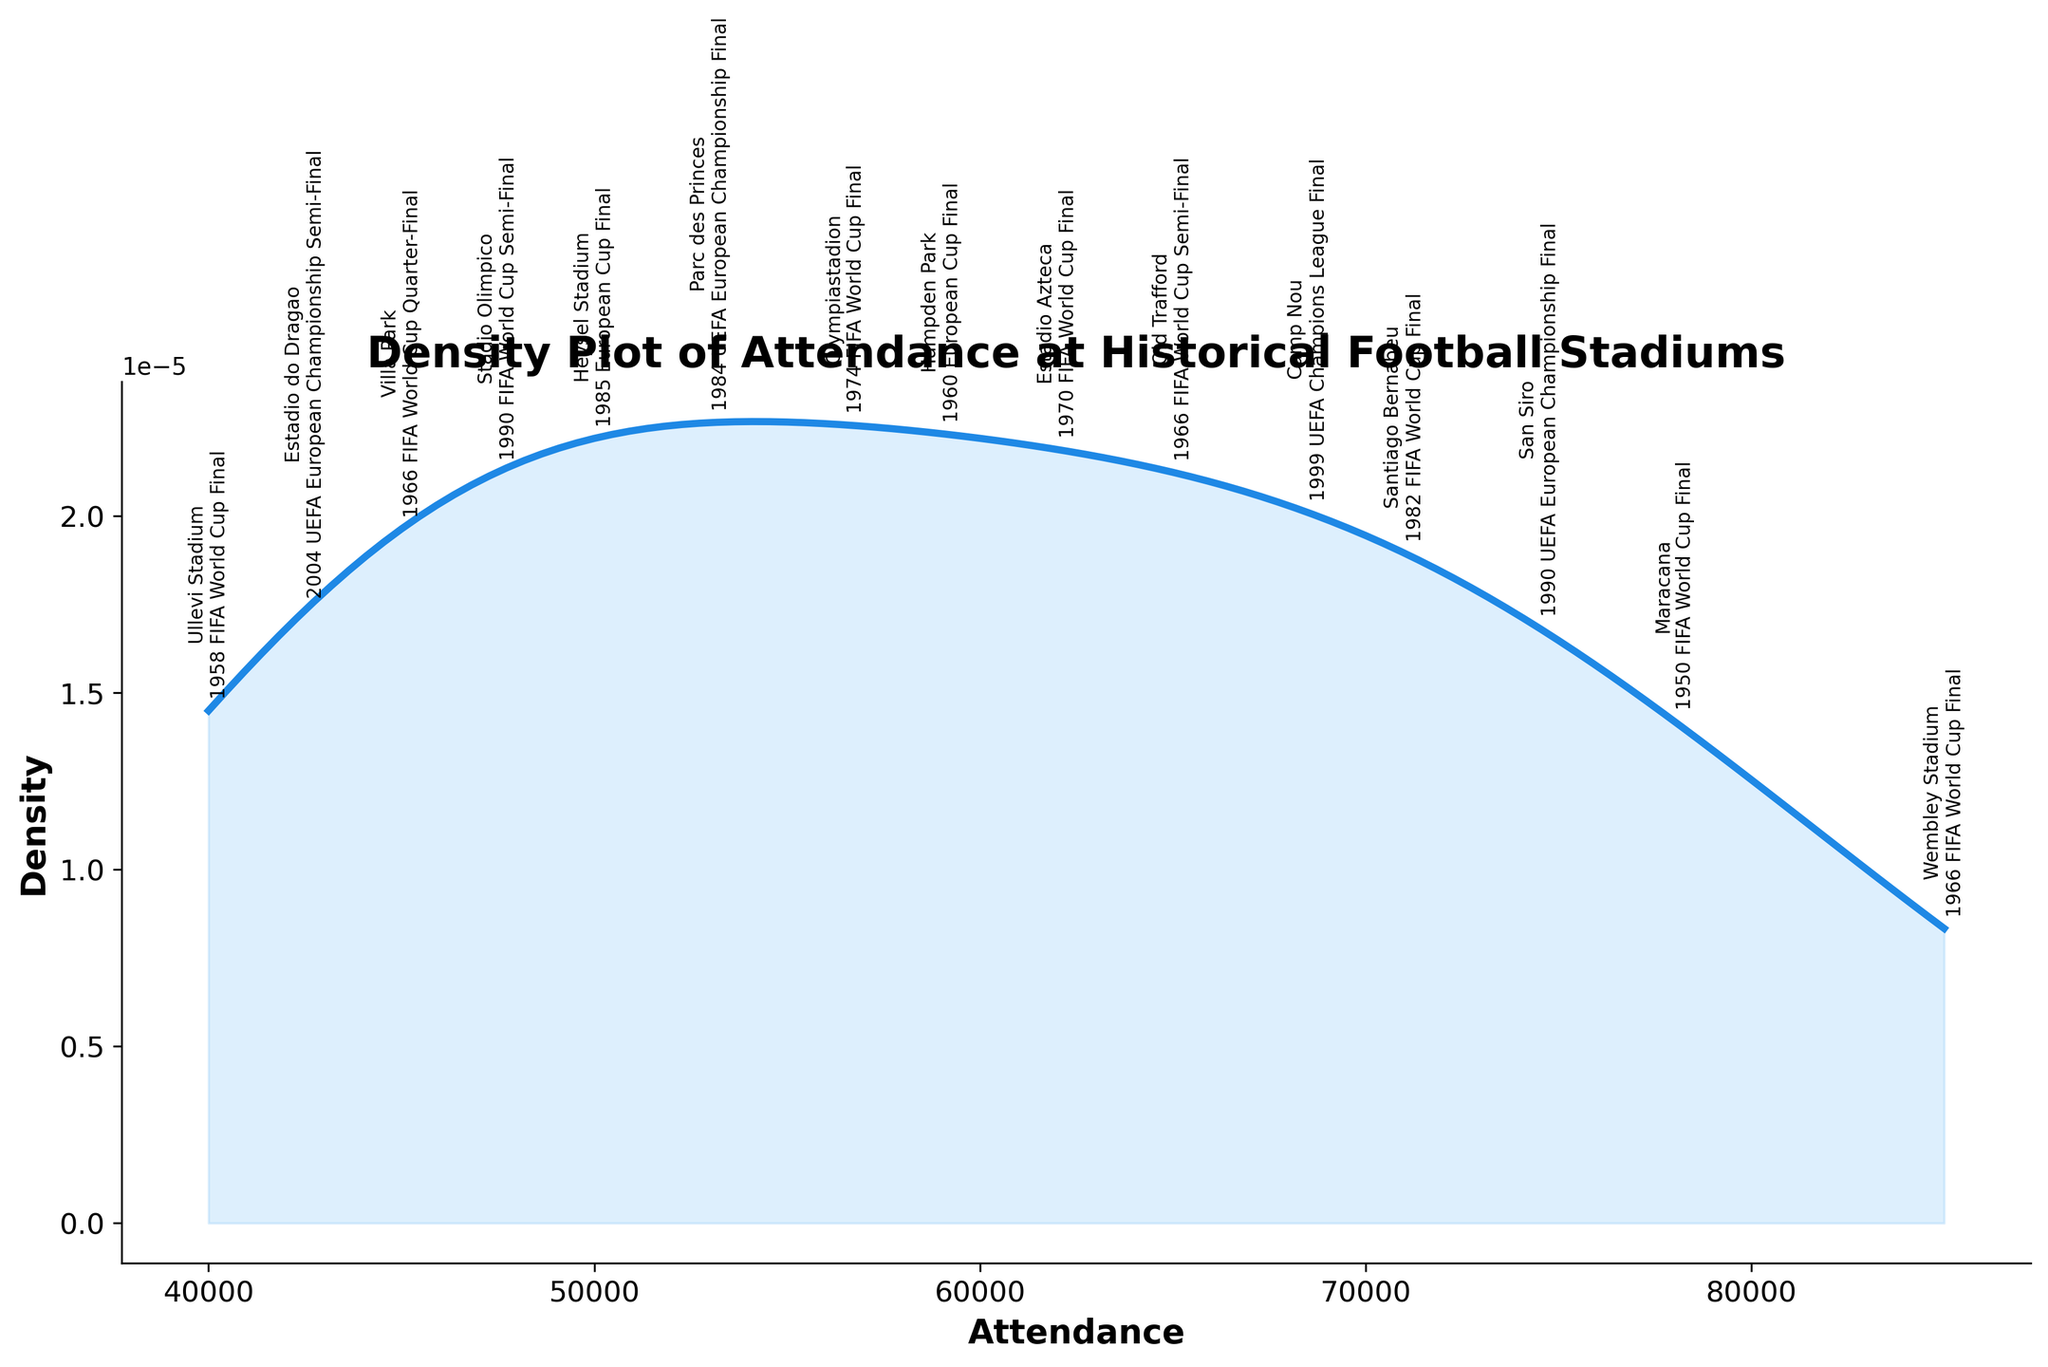What is the title of the plot? The title of the plot is usually written at the top center of the figure. From the visual, it reads "Density Plot of Attendance at Historical Football Stadiums."
Answer: Density Plot of Attendance at Historical Football Stadiums What is the highest peak of the density curve? To determine the highest peak of the density curve, look at the y-axis and identify the maximum value reached by the curve itself.
Answer: Approximately 1.5e-05 Which historical stadium had the highest attendance in a significant match? Look at the annotations on the curve and find the stadium with the highest value on the x-axis. The highest attendance was recorded at Wembley Stadium for the 1966 FIFA World Cup Final.
Answer: Wembley Stadium What is the attendance range covered in the plot? The x-axis displays the range of attendance values. It spans from the minimum attendance value to the maximum attendance value. The range is from 40,000 to 85,000.
Answer: 40,000 to 85,000 How does the density of matches at Maracana Stadium compare to those at Old Trafford? Compare the marked positions on the density plot for both Maracana and Old Trafford. The peak density for Maracana is near the higher end of the attendance range, whereas Old Trafford's density is slightly lower and broader.
Answer: Maracana has a higher peak density What's the approximate attendance for the highest density on the plot? Locate the peak of the density curve and trace it down to the corresponding value on the x-axis, which shows attendance. It's approximately around 50,000.
Answer: Around 50,000 Which stadium hosted a match with an attendance around 58,000? Look for the annotation near the 58,000 attendance mark on the x-axis. Hampden Park hosted a match with approximately 59,000 attendance.
Answer: Hampden Park What can you say about the density around the 70,000 mark? Examine the area around the 70,000 mark on the x-axis and see the density's height. There's a noticeable peak indicating a significant number of matches around this attendance.
Answer: There is a noticeable peak indicating higher density What is the general trend of the density curve for attendance values from 40,000 to 65,000? From the start (40,000) to around 65,000 on the x-axis, observe the slope and height changes of the density curve. The curve gradually rises to a peak and then dips slightly until around 65,000.
Answer: Gradually rises to a peak and then dips Why might the plot show multiple peaks? Density plots depict the frequency of attendance values. Multiple peaks suggest that several distinct attendance numbers were common during significant matches, possibly because of varying stadium capacities and events.
Answer: Suggests different common attendance values 